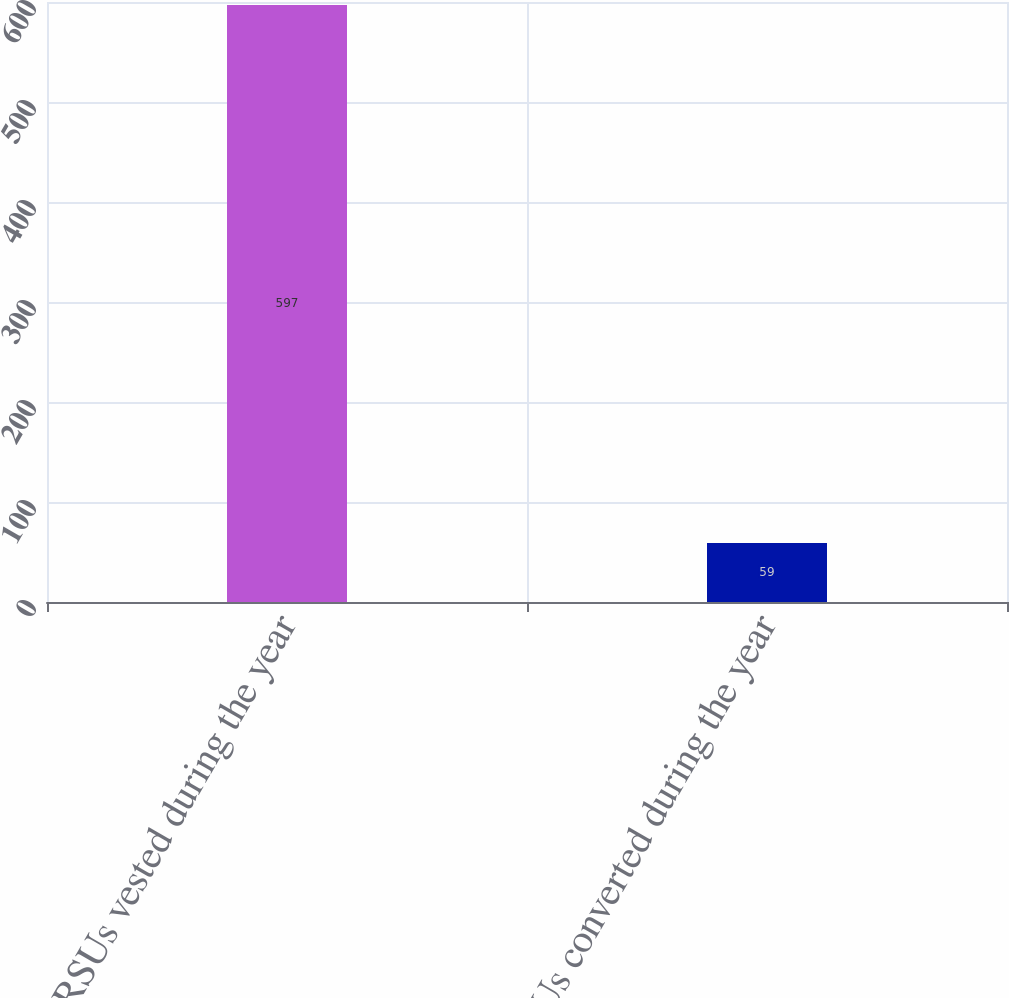Convert chart. <chart><loc_0><loc_0><loc_500><loc_500><bar_chart><fcel>RSUs vested during the year<fcel>RSUs converted during the year<nl><fcel>597<fcel>59<nl></chart> 